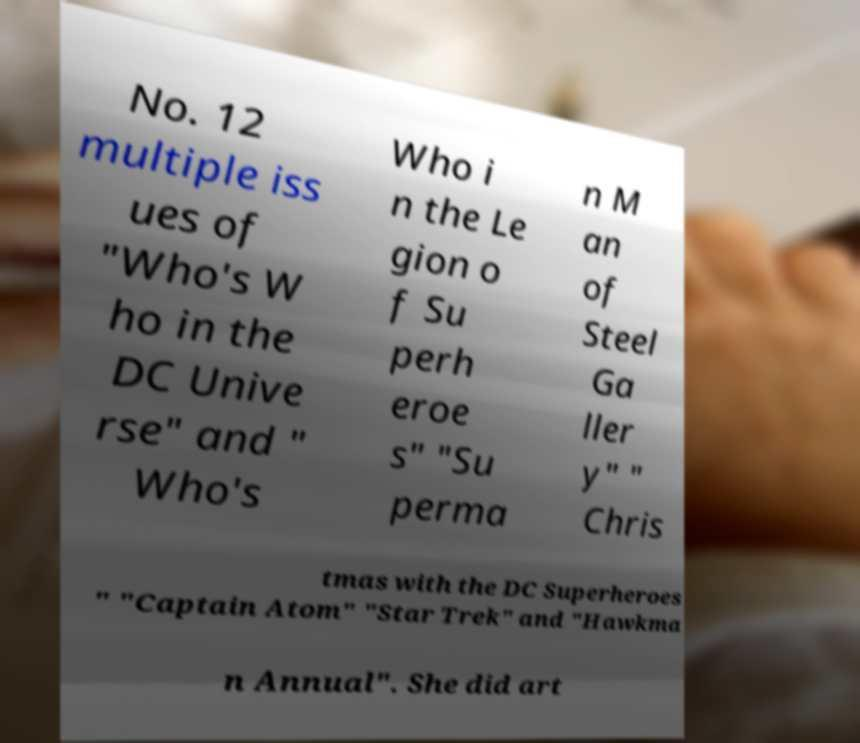For documentation purposes, I need the text within this image transcribed. Could you provide that? No. 12 multiple iss ues of "Who's W ho in the DC Unive rse" and " Who's Who i n the Le gion o f Su perh eroe s" "Su perma n M an of Steel Ga ller y" " Chris tmas with the DC Superheroes " "Captain Atom" "Star Trek" and "Hawkma n Annual". She did art 